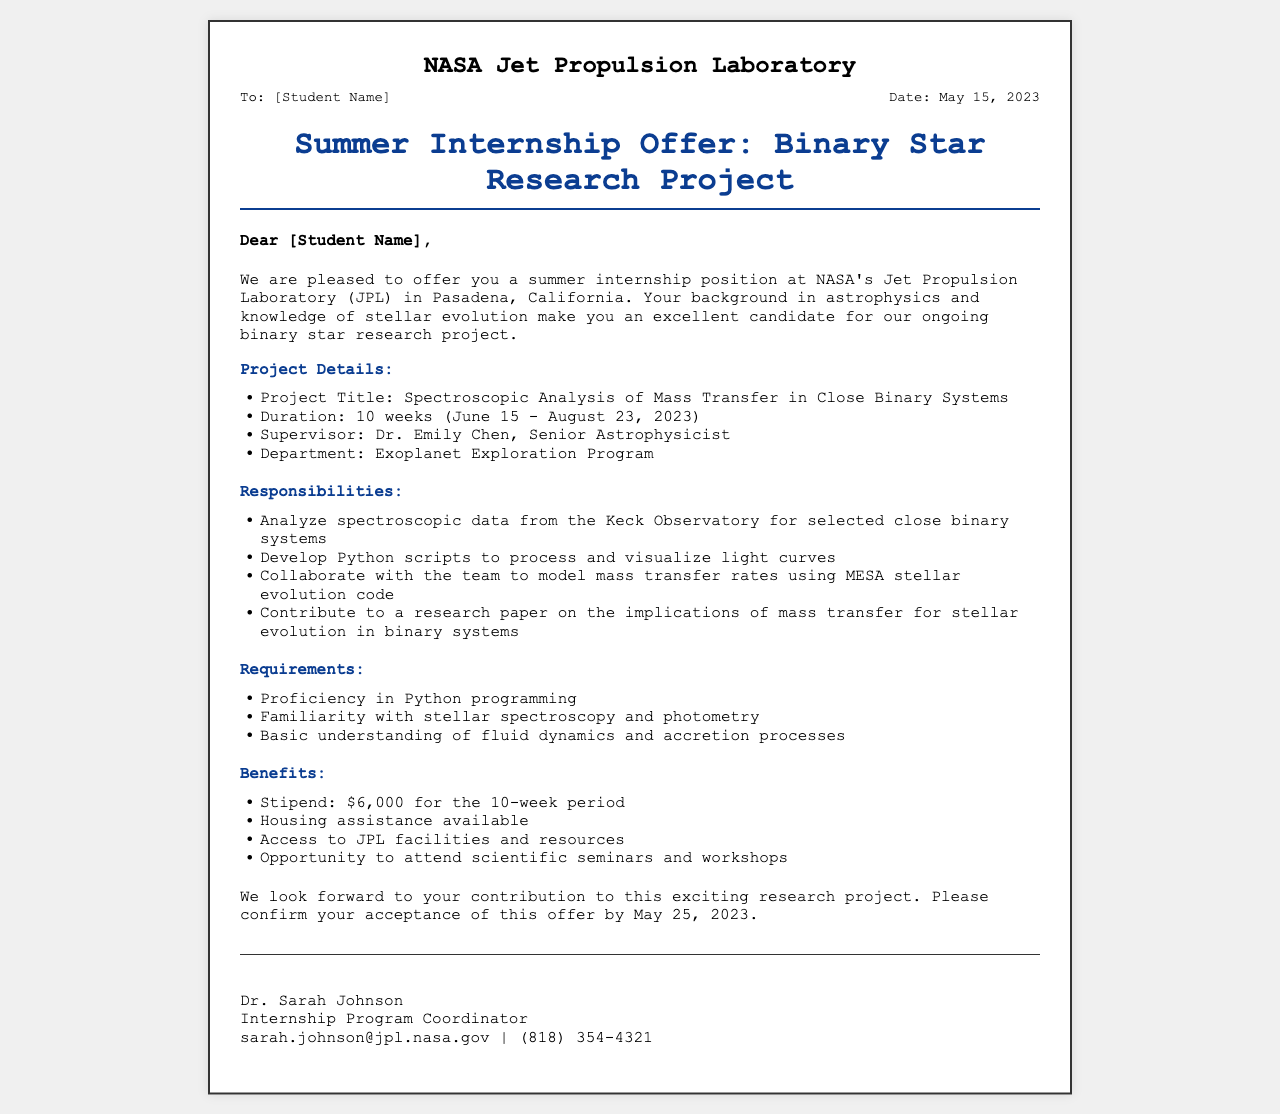What is the project title? The project title is specified in the project details section.
Answer: Spectroscopic Analysis of Mass Transfer in Close Binary Systems Who is the supervisor of the internship? The supervisor's name is listed in the project details section.
Answer: Dr. Emily Chen What is the duration of the internship? The duration is mentioned as a timeframe in the project details section.
Answer: 10 weeks What are the responsibilities related to data analysis? One of the responsibilities entails analyzing specific data as noted in the responsibilities section.
Answer: Analyze spectroscopic data from the Keck Observatory for selected close binary systems What is the stipend amount for the internship? The stipend amount is explicitly mentioned in the benefits section.
Answer: $6,000 What is the deadline to confirm acceptance of the offer? The deadline is provided in the final paragraph of the document.
Answer: May 25, 2023 What department is overseeing the project? The departmental affiliation is listed in the project details section.
Answer: Exoplanet Exploration Program What programming language is required for the internship? The specific programming requirement is noted in the requirements section.
Answer: Python 